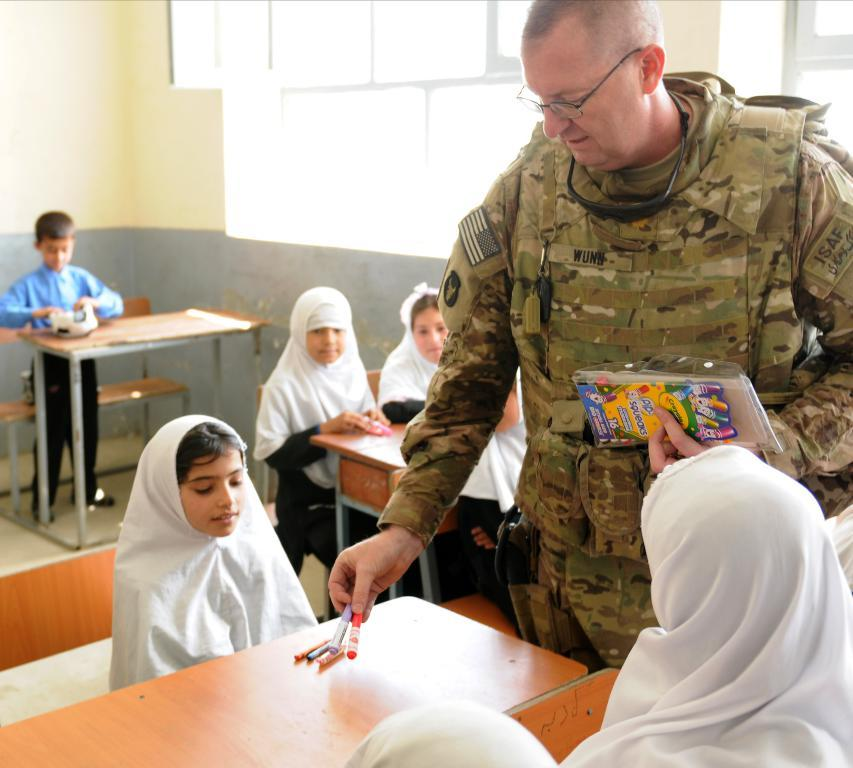How many people are in the image? There is a group of people in the image. What are some of the people in the image doing? Some people are seated on chairs. What is the man holding in his hand? The man is holding color pencils in his hand. What is the man doing with the color pencils? The man is distributing pencils to children. Can you hear the people in the image laughing while the man records his knee? There is no mention of laughter or recording in the image, nor is there any indication that the man's knee is being recorded. 